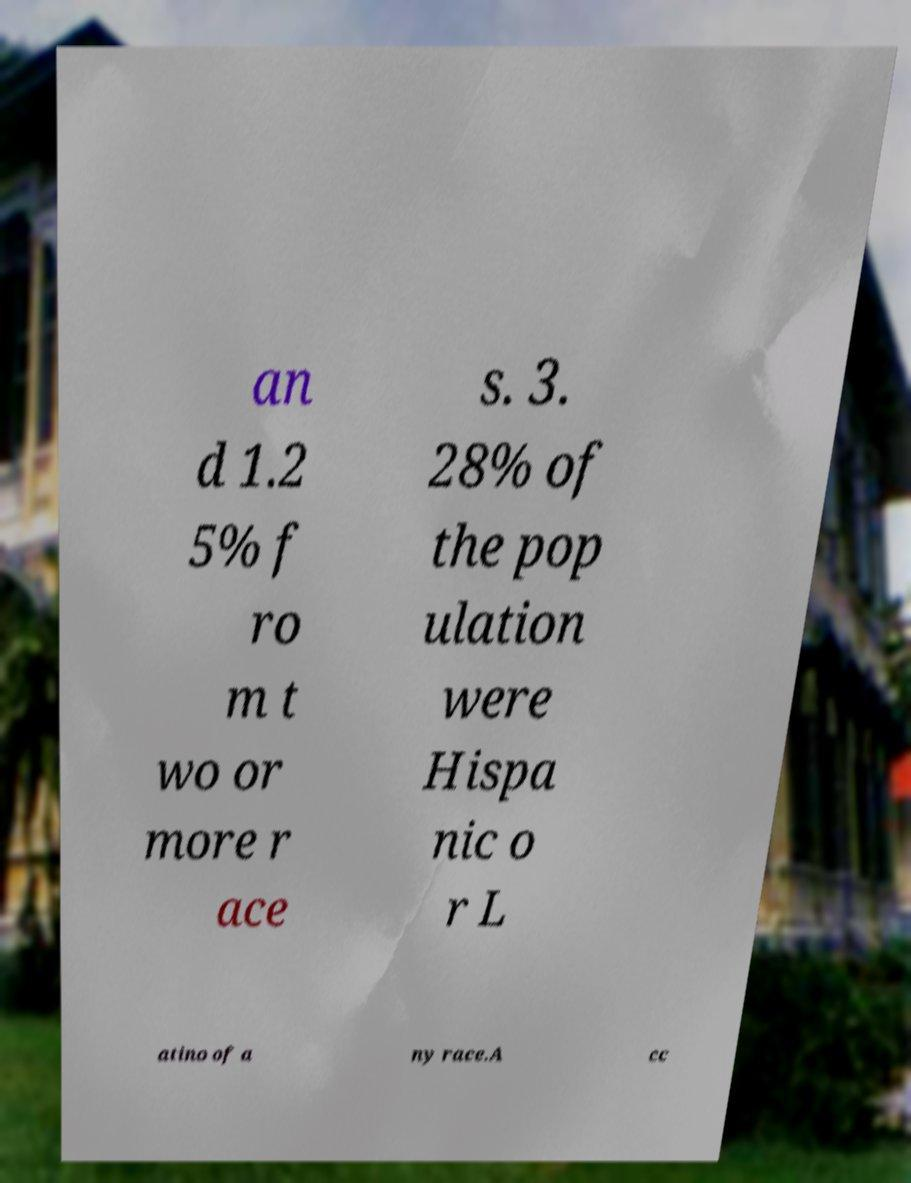Can you accurately transcribe the text from the provided image for me? an d 1.2 5% f ro m t wo or more r ace s. 3. 28% of the pop ulation were Hispa nic o r L atino of a ny race.A cc 